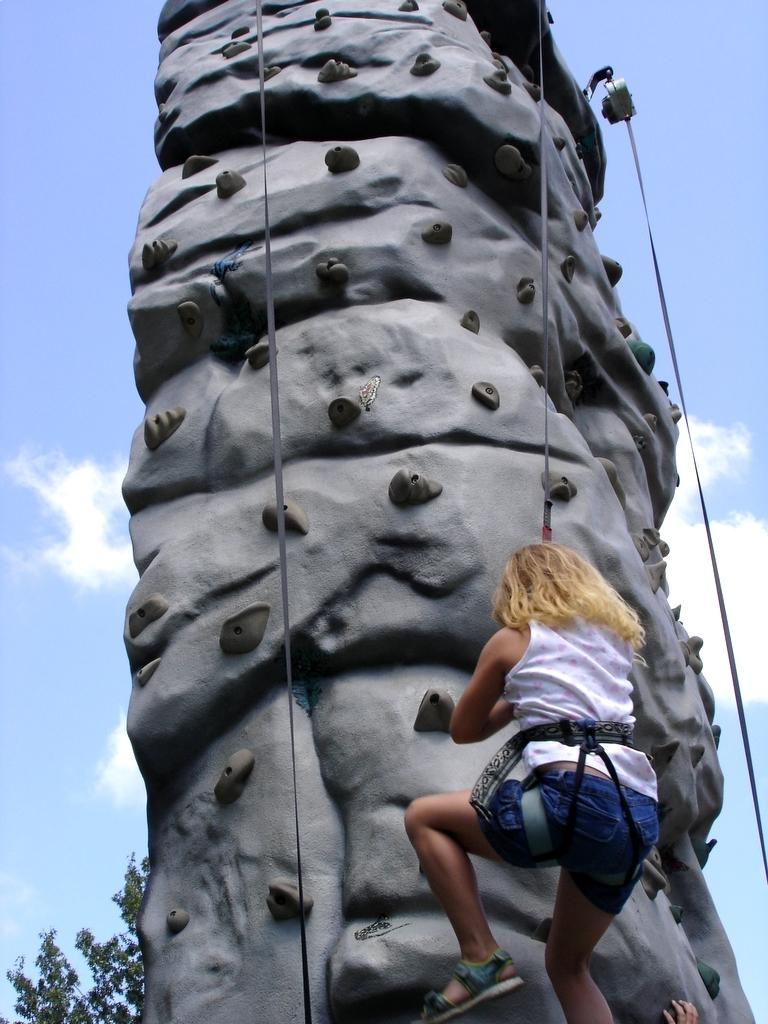What activity is the person in the image engaged in? The person is performing the sport of climbing in the image. What can be seen in the background of the image? There are clouds visible in the sky in the background of the image. What type of farm animals can be seen grazing in the image? There are no farm animals present in the image; it features a person climbing and clouds in the sky. 